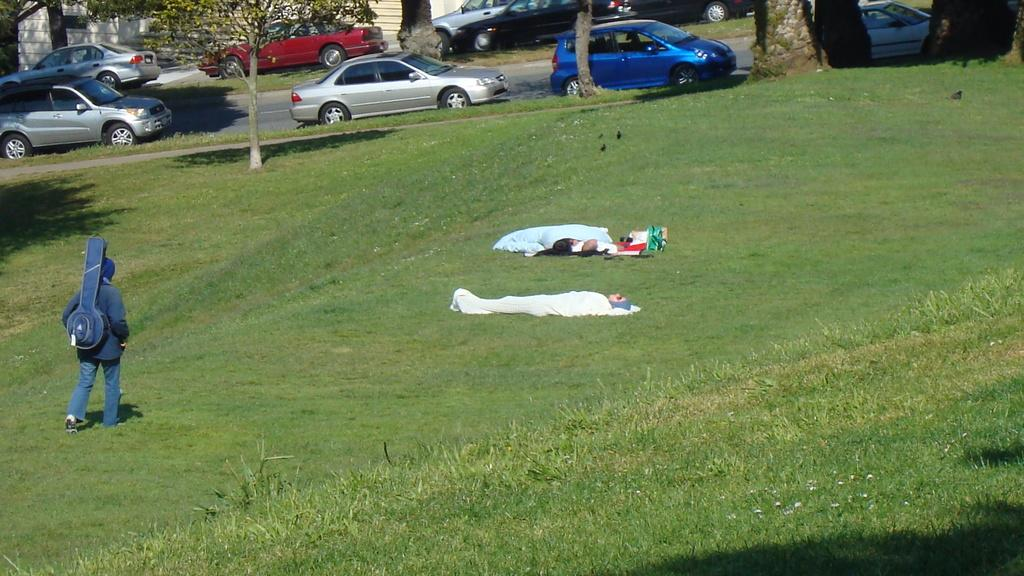What type of vegetation is present on the ground in the front of the image? There is grass on the ground in the front of the image. What are the persons in the center of the image doing? The persons in the center of the image are walking and laying. What can be seen in the background of the image? There are trees, cars, and a wall in the background of the image. How many horses are standing on the shelf in the image? There are no horses or shelves present in the image. What color is the pencil being used by the person in the image? There is no pencil visible in the image. 